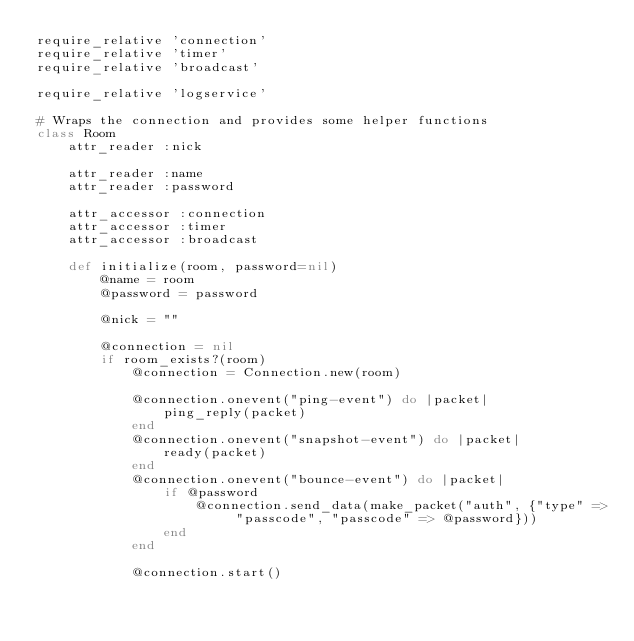<code> <loc_0><loc_0><loc_500><loc_500><_Ruby_>require_relative 'connection'
require_relative 'timer'
require_relative 'broadcast'

require_relative 'logservice'

# Wraps the connection and provides some helper functions
class Room
    attr_reader :nick

    attr_reader :name
    attr_reader :password

    attr_accessor :connection
    attr_accessor :timer
    attr_accessor :broadcast

    def initialize(room, password=nil)
        @name = room
        @password = password

        @nick = ""

        @connection = nil
        if room_exists?(room)
            @connection = Connection.new(room)

            @connection.onevent("ping-event") do |packet|
                ping_reply(packet)
            end
            @connection.onevent("snapshot-event") do |packet|
                ready(packet)
            end
            @connection.onevent("bounce-event") do |packet|
                if @password
                    @connection.send_data(make_packet("auth", {"type" => "passcode", "passcode" => @password}))
                end
            end

            @connection.start()</code> 